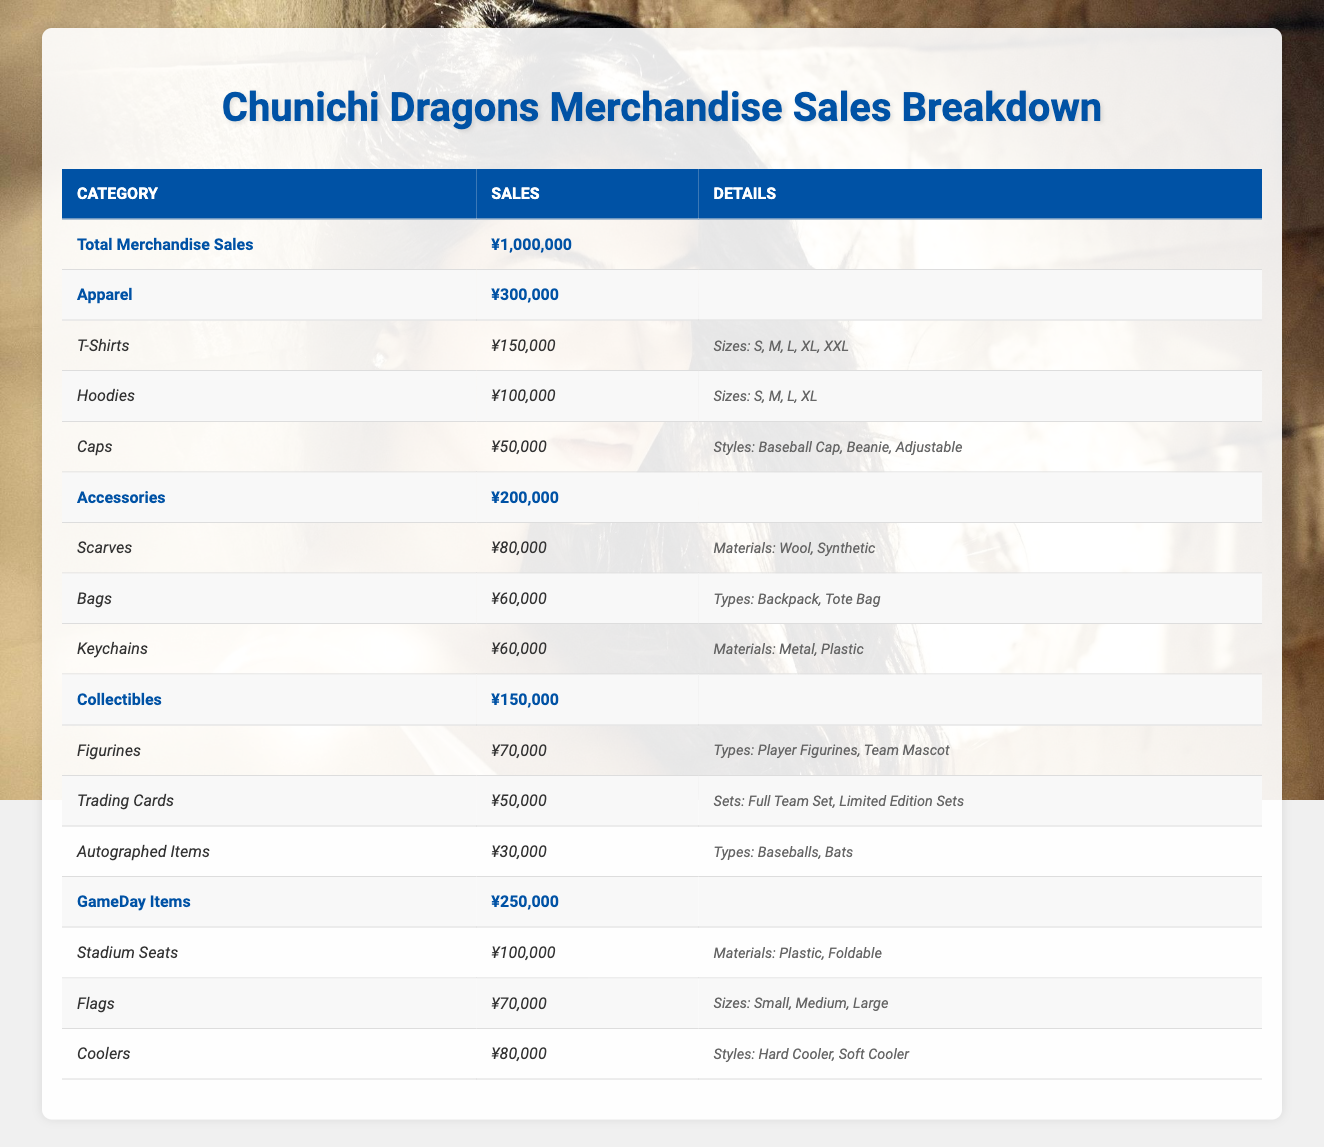What are the total sales for the Chunichi Dragons merchandise? The table shows the total merchandise sales for the Chunichi Dragons as ¥1,000,000 in the first row.
Answer: ¥1,000,000 Which category has the highest total sales? The categories in the table are Apparel (¥300,000), Accessories (¥200,000), Collectibles (¥150,000), and GameDay Items (¥250,000). Apparel has the highest total sales of ¥300,000.
Answer: Apparel How much do the collectible items total? The collectibles category has a total sales value of ¥150,000, which is stated in the corresponding row.
Answer: ¥150,000 What is the total sales for accessories and game day items combined? The accessories total sales is ¥200,000, and game day items total sales is ¥250,000. Adding these together gives ¥200,000 + ¥250,000 = ¥450,000.
Answer: ¥450,000 Are there any items that sell for less than ¥60,000 in the accessories category? The accessories category has three items: Scarves (¥80,000), Bags (¥60,000), and Keychains (¥60,000). None of these items sell for less than ¥60,000.
Answer: No What percentage of the total merchandise sales do apparel sales represent? Apparel sales total ¥300,000 and total merchandise sales are ¥1,000,000. To find the percentage, calculate (300,000 / 1,000,000) * 100 = 30%.
Answer: 30% Which item has the lowest total sales within the collectibles category? The collectibles category includes Figurines (¥70,000), Trading Cards (¥50,000), and Autographed Items (¥30,000). Autographed Items has the lowest sales at ¥30,000.
Answer: Autographed Items How many items are available for sale in the apparel category? The apparel category has three different items listed: T-Shirts, Hoodies, and Caps, resulting in a total of three items available for sale.
Answer: 3 If you consider only apparel and accessories, what is the difference in their total sales? Apparel sales total ¥300,000 and accessory sales total ¥200,000. The difference is calculated as ¥300,000 - ¥200,000 = ¥100,000.
Answer: ¥100,000 